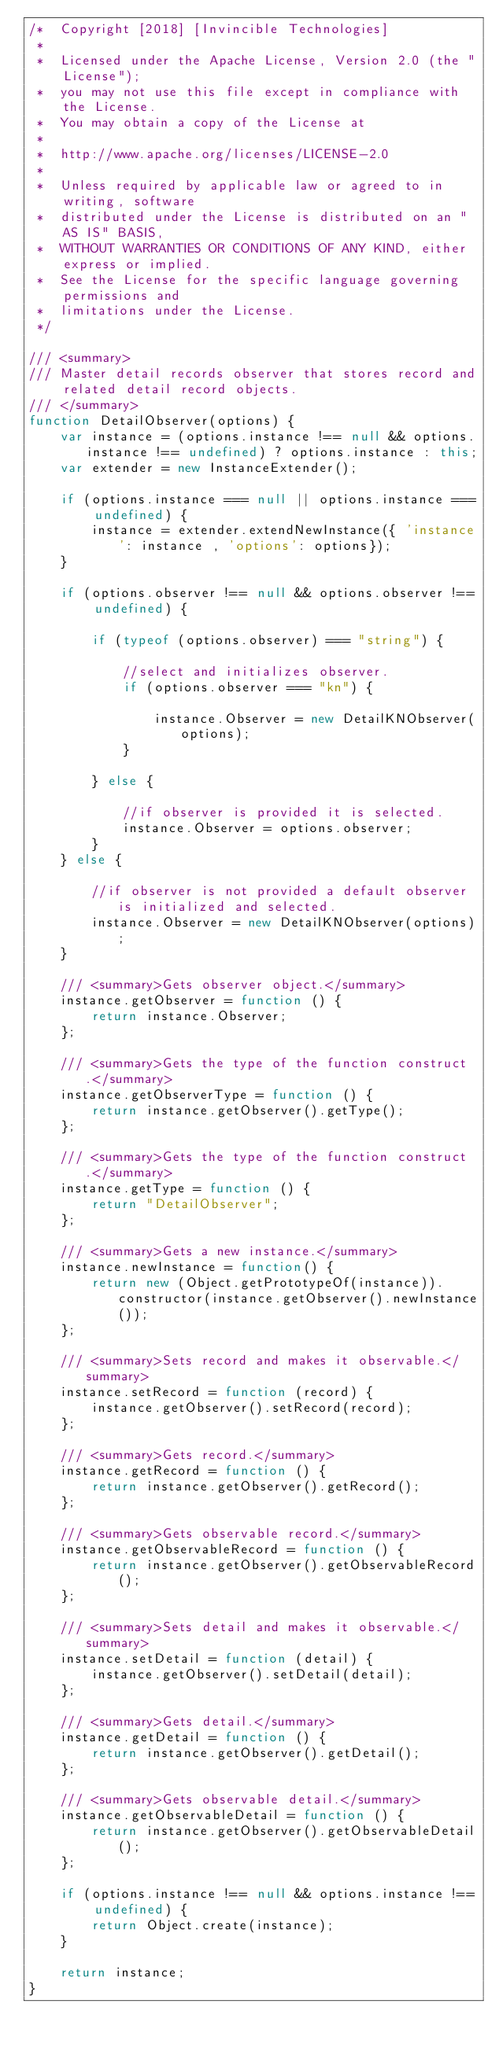<code> <loc_0><loc_0><loc_500><loc_500><_JavaScript_>/*  Copyright [2018] [Invincible Technologies]
 *  
 *  Licensed under the Apache License, Version 2.0 (the "License");
 *  you may not use this file except in compliance with the License.
 *  You may obtain a copy of the License at
 *
 *  http://www.apache.org/licenses/LICENSE-2.0
 *    
 *  Unless required by applicable law or agreed to in writing, software
 *  distributed under the License is distributed on an "AS IS" BASIS,
 *  WITHOUT WARRANTIES OR CONDITIONS OF ANY KIND, either express or implied.
 *  See the License for the specific language governing permissions and
 *  limitations under the License.
 */

/// <summary>
/// Master detail records observer that stores record and related detail record objects.
/// </summary>
function DetailObserver(options) {
    var instance = (options.instance !== null && options.instance !== undefined) ? options.instance : this;
    var extender = new InstanceExtender();
    
    if (options.instance === null || options.instance === undefined) {
        instance = extender.extendNewInstance({ 'instance': instance , 'options': options});
    }
    
    if (options.observer !== null && options.observer !== undefined) {

        if (typeof (options.observer) === "string") {

            //select and initializes observer.
            if (options.observer === "kn") {
                
                instance.Observer = new DetailKNObserver(options);
            }

        } else {

            //if observer is provided it is selected.
            instance.Observer = options.observer;
        }
    } else {
        
        //if observer is not provided a default observer is initialized and selected.
        instance.Observer = new DetailKNObserver(options);
    }
    
    /// <summary>Gets observer object.</summary>
    instance.getObserver = function () {
        return instance.Observer;
    };
    
    /// <summary>Gets the type of the function construct.</summary>
    instance.getObserverType = function () {
        return instance.getObserver().getType();
    };
    
    /// <summary>Gets the type of the function construct.</summary>
    instance.getType = function () {
        return "DetailObserver";
    };
    
    /// <summary>Gets a new instance.</summary>
    instance.newInstance = function() {
        return new (Object.getPrototypeOf(instance)).constructor(instance.getObserver().newInstance());
    };

    /// <summary>Sets record and makes it observable.</summary>
    instance.setRecord = function (record) {
        instance.getObserver().setRecord(record);
    };

    /// <summary>Gets record.</summary>
    instance.getRecord = function () {
        return instance.getObserver().getRecord();
    };

    /// <summary>Gets observable record.</summary>
    instance.getObservableRecord = function () {
        return instance.getObserver().getObservableRecord();
    };

    /// <summary>Sets detail and makes it observable.</summary>
    instance.setDetail = function (detail) {
        instance.getObserver().setDetail(detail);
    };

    /// <summary>Gets detail.</summary>
    instance.getDetail = function () {
        return instance.getObserver().getDetail();
    };

    /// <summary>Gets observable detail.</summary>
    instance.getObservableDetail = function () {
        return instance.getObserver().getObservableDetail();
    };
    
    if (options.instance !== null && options.instance !== undefined) {
        return Object.create(instance);
    }
    
    return instance;
}</code> 